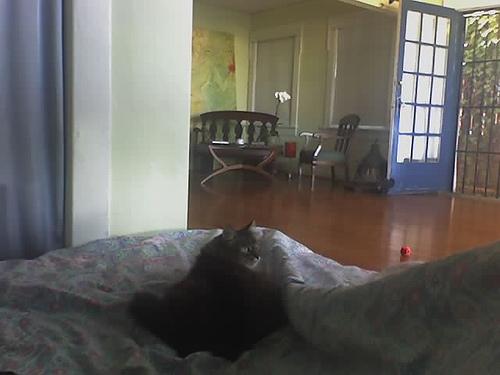Is the door open?
Concise answer only. Yes. What color is the door?
Give a very brief answer. Blue. Is this cat leaning on a human?
Answer briefly. No. What kind of pet is in the picture?
Quick response, please. Cat. Is this cat's eyes closed or open?
Write a very short answer. Open. 